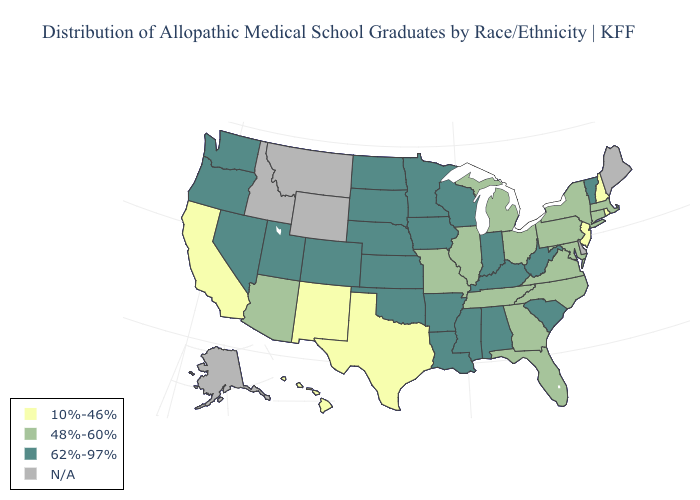Name the states that have a value in the range 10%-46%?
Short answer required. California, Hawaii, New Hampshire, New Jersey, New Mexico, Rhode Island, Texas. Does the map have missing data?
Give a very brief answer. Yes. What is the lowest value in the South?
Concise answer only. 10%-46%. What is the value of Hawaii?
Be succinct. 10%-46%. Name the states that have a value in the range 48%-60%?
Short answer required. Arizona, Connecticut, Florida, Georgia, Illinois, Maryland, Massachusetts, Michigan, Missouri, New York, North Carolina, Ohio, Pennsylvania, Tennessee, Virginia. Name the states that have a value in the range N/A?
Quick response, please. Alaska, Delaware, Idaho, Maine, Montana, Wyoming. Name the states that have a value in the range 10%-46%?
Give a very brief answer. California, Hawaii, New Hampshire, New Jersey, New Mexico, Rhode Island, Texas. What is the value of Massachusetts?
Give a very brief answer. 48%-60%. What is the value of Washington?
Concise answer only. 62%-97%. Name the states that have a value in the range 48%-60%?
Concise answer only. Arizona, Connecticut, Florida, Georgia, Illinois, Maryland, Massachusetts, Michigan, Missouri, New York, North Carolina, Ohio, Pennsylvania, Tennessee, Virginia. Name the states that have a value in the range N/A?
Answer briefly. Alaska, Delaware, Idaho, Maine, Montana, Wyoming. What is the value of West Virginia?
Short answer required. 62%-97%. Name the states that have a value in the range 48%-60%?
Give a very brief answer. Arizona, Connecticut, Florida, Georgia, Illinois, Maryland, Massachusetts, Michigan, Missouri, New York, North Carolina, Ohio, Pennsylvania, Tennessee, Virginia. Does the map have missing data?
Write a very short answer. Yes. Name the states that have a value in the range N/A?
Keep it brief. Alaska, Delaware, Idaho, Maine, Montana, Wyoming. 